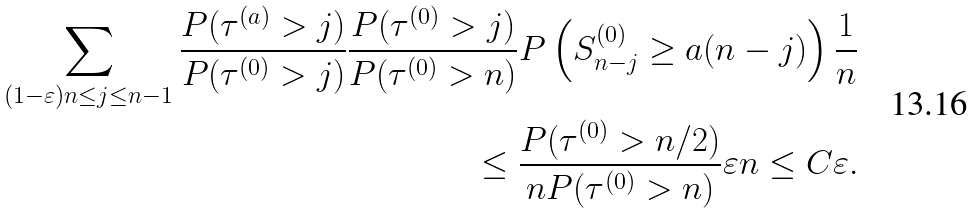Convert formula to latex. <formula><loc_0><loc_0><loc_500><loc_500>\sum _ { ( 1 - \varepsilon ) n \leq j \leq n - 1 } \frac { P ( \tau ^ { ( a ) } > j ) } { P ( \tau ^ { ( 0 ) } > j ) } \frac { P ( \tau ^ { ( 0 ) } > j ) } { P ( \tau ^ { ( 0 ) } > n ) } P \left ( S ^ { ( 0 ) } _ { n - j } \geq a ( n - j ) \right ) \frac { 1 } { n } \\ \leq \frac { P ( \tau ^ { ( 0 ) } > n / 2 ) } { n P ( \tau ^ { ( 0 ) } > n ) } \varepsilon n \leq C \varepsilon .</formula> 